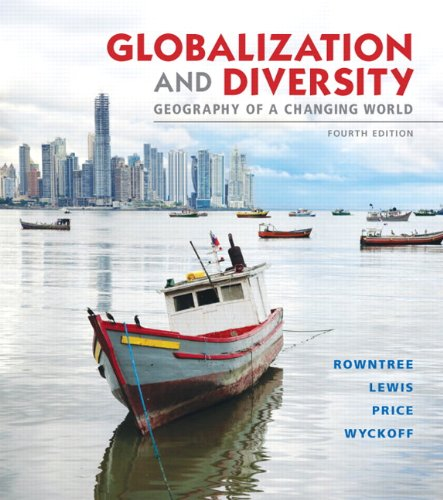What themes are explored in this book related to globalization? The book 'Globalization and Diversity' delves into themes such as economic disparities, cultural exchanges, and the environmental impacts brought about by global integration, examining how these factors shape local geographies. 